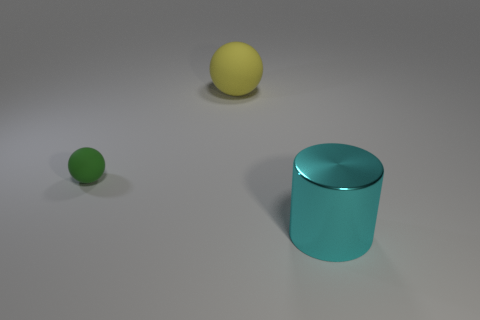Subtract all yellow spheres. How many spheres are left? 1 Add 1 blue metal blocks. How many objects exist? 4 Subtract 0 purple cubes. How many objects are left? 3 Subtract all cylinders. How many objects are left? 2 Subtract all cyan spheres. Subtract all green cylinders. How many spheres are left? 2 Subtract all blue cylinders. How many blue spheres are left? 0 Subtract all big purple metal cylinders. Subtract all big cyan shiny objects. How many objects are left? 2 Add 2 cyan metal objects. How many cyan metal objects are left? 3 Add 3 yellow rubber things. How many yellow rubber things exist? 4 